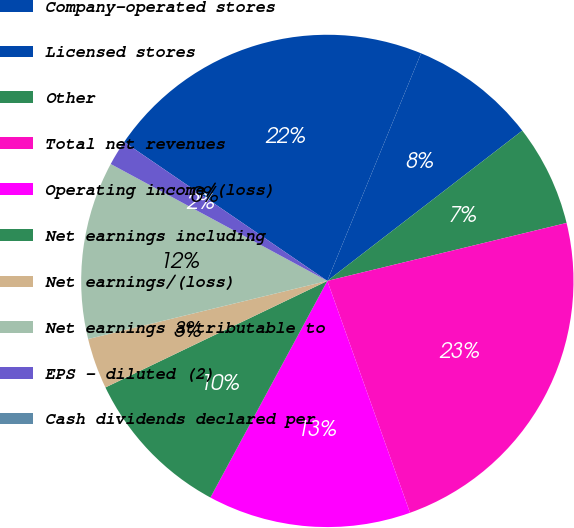Convert chart. <chart><loc_0><loc_0><loc_500><loc_500><pie_chart><fcel>Company-operated stores<fcel>Licensed stores<fcel>Other<fcel>Total net revenues<fcel>Operating income/(loss)<fcel>Net earnings including<fcel>Net earnings/(loss)<fcel>Net earnings attributable to<fcel>EPS - diluted (2)<fcel>Cash dividends declared per<nl><fcel>21.67%<fcel>8.33%<fcel>6.67%<fcel>23.33%<fcel>13.33%<fcel>10.0%<fcel>3.33%<fcel>11.67%<fcel>1.67%<fcel>0.0%<nl></chart> 